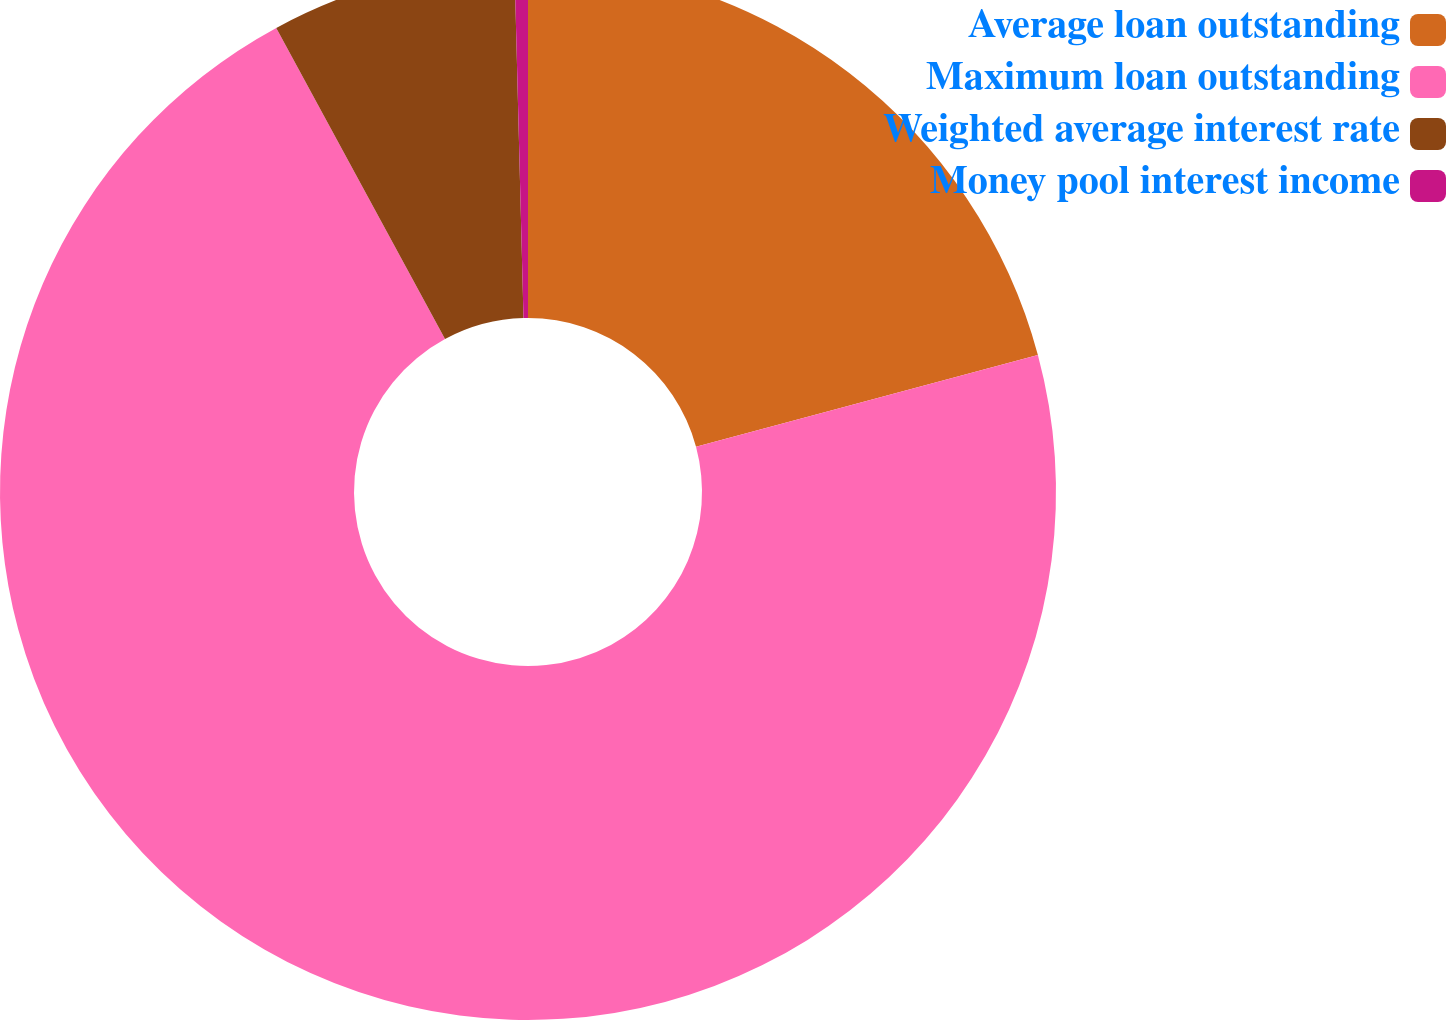Convert chart to OTSL. <chart><loc_0><loc_0><loc_500><loc_500><pie_chart><fcel>Average loan outstanding<fcel>Maximum loan outstanding<fcel>Weighted average interest rate<fcel>Money pool interest income<nl><fcel>20.82%<fcel>71.27%<fcel>7.5%<fcel>0.41%<nl></chart> 